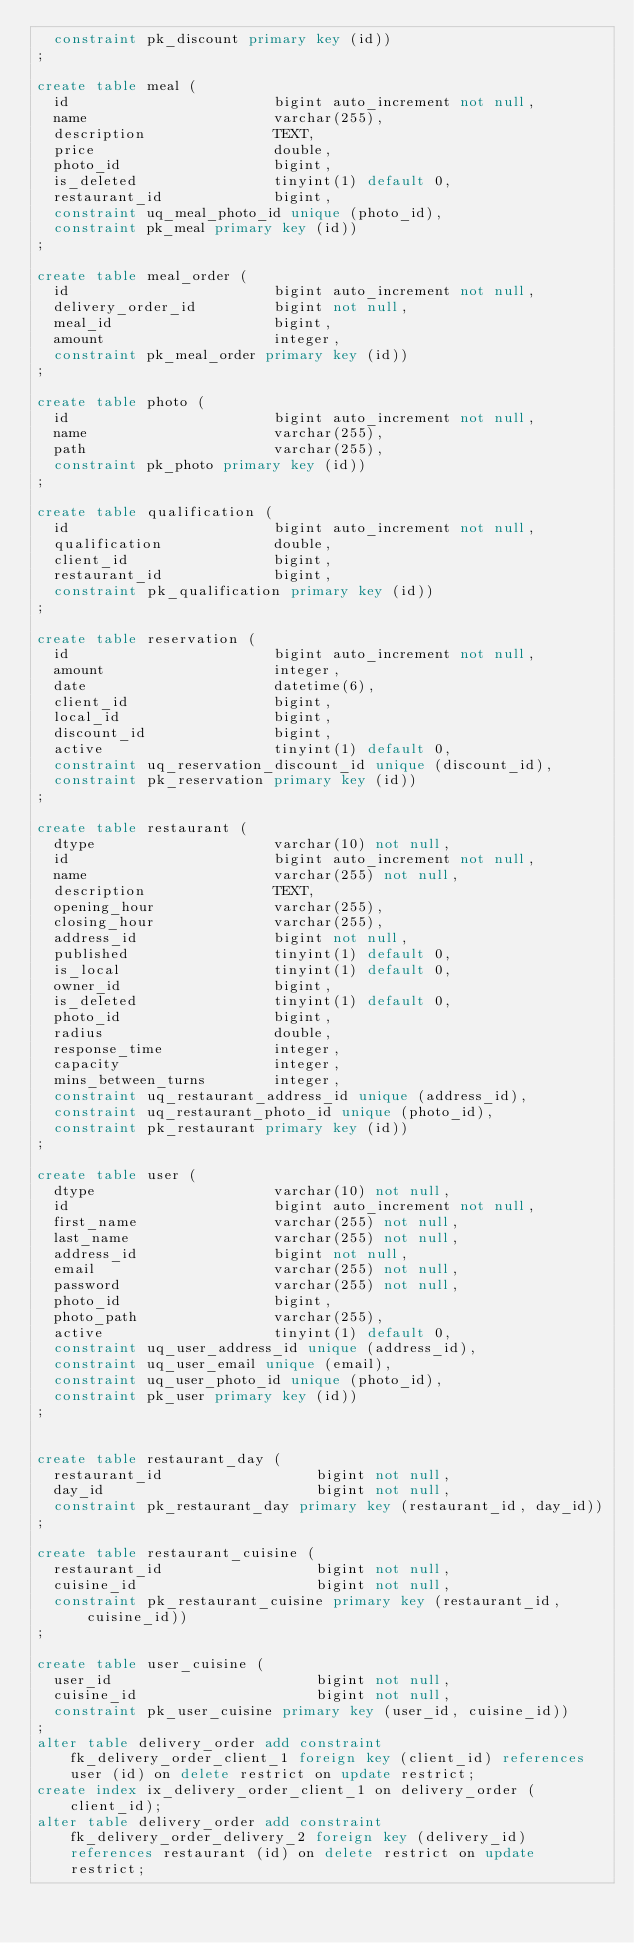<code> <loc_0><loc_0><loc_500><loc_500><_SQL_>  constraint pk_discount primary key (id))
;

create table meal (
  id                        bigint auto_increment not null,
  name                      varchar(255),
  description               TEXT,
  price                     double,
  photo_id                  bigint,
  is_deleted                tinyint(1) default 0,
  restaurant_id             bigint,
  constraint uq_meal_photo_id unique (photo_id),
  constraint pk_meal primary key (id))
;

create table meal_order (
  id                        bigint auto_increment not null,
  delivery_order_id         bigint not null,
  meal_id                   bigint,
  amount                    integer,
  constraint pk_meal_order primary key (id))
;

create table photo (
  id                        bigint auto_increment not null,
  name                      varchar(255),
  path                      varchar(255),
  constraint pk_photo primary key (id))
;

create table qualification (
  id                        bigint auto_increment not null,
  qualification             double,
  client_id                 bigint,
  restaurant_id             bigint,
  constraint pk_qualification primary key (id))
;

create table reservation (
  id                        bigint auto_increment not null,
  amount                    integer,
  date                      datetime(6),
  client_id                 bigint,
  local_id                  bigint,
  discount_id               bigint,
  active                    tinyint(1) default 0,
  constraint uq_reservation_discount_id unique (discount_id),
  constraint pk_reservation primary key (id))
;

create table restaurant (
  dtype                     varchar(10) not null,
  id                        bigint auto_increment not null,
  name                      varchar(255) not null,
  description               TEXT,
  opening_hour              varchar(255),
  closing_hour              varchar(255),
  address_id                bigint not null,
  published                 tinyint(1) default 0,
  is_local                  tinyint(1) default 0,
  owner_id                  bigint,
  is_deleted                tinyint(1) default 0,
  photo_id                  bigint,
  radius                    double,
  response_time             integer,
  capacity                  integer,
  mins_between_turns        integer,
  constraint uq_restaurant_address_id unique (address_id),
  constraint uq_restaurant_photo_id unique (photo_id),
  constraint pk_restaurant primary key (id))
;

create table user (
  dtype                     varchar(10) not null,
  id                        bigint auto_increment not null,
  first_name                varchar(255) not null,
  last_name                 varchar(255) not null,
  address_id                bigint not null,
  email                     varchar(255) not null,
  password                  varchar(255) not null,
  photo_id                  bigint,
  photo_path                varchar(255),
  active                    tinyint(1) default 0,
  constraint uq_user_address_id unique (address_id),
  constraint uq_user_email unique (email),
  constraint uq_user_photo_id unique (photo_id),
  constraint pk_user primary key (id))
;


create table restaurant_day (
  restaurant_id                  bigint not null,
  day_id                         bigint not null,
  constraint pk_restaurant_day primary key (restaurant_id, day_id))
;

create table restaurant_cuisine (
  restaurant_id                  bigint not null,
  cuisine_id                     bigint not null,
  constraint pk_restaurant_cuisine primary key (restaurant_id, cuisine_id))
;

create table user_cuisine (
  user_id                        bigint not null,
  cuisine_id                     bigint not null,
  constraint pk_user_cuisine primary key (user_id, cuisine_id))
;
alter table delivery_order add constraint fk_delivery_order_client_1 foreign key (client_id) references user (id) on delete restrict on update restrict;
create index ix_delivery_order_client_1 on delivery_order (client_id);
alter table delivery_order add constraint fk_delivery_order_delivery_2 foreign key (delivery_id) references restaurant (id) on delete restrict on update restrict;</code> 